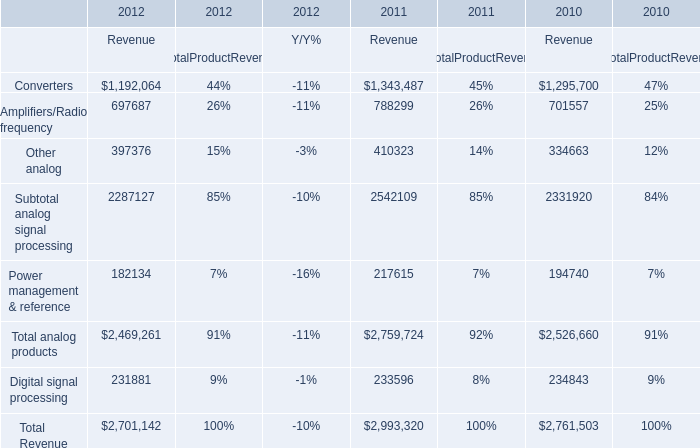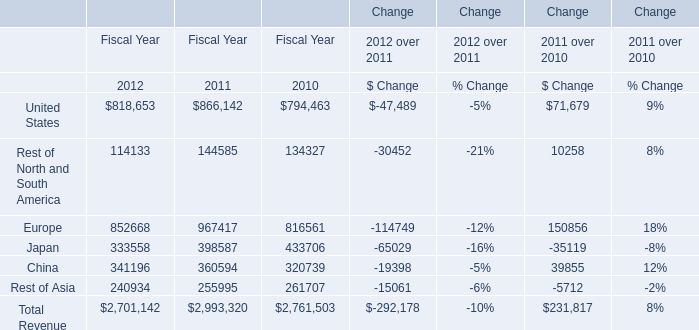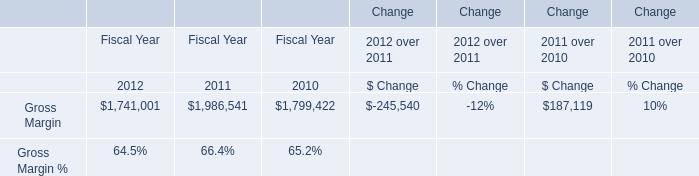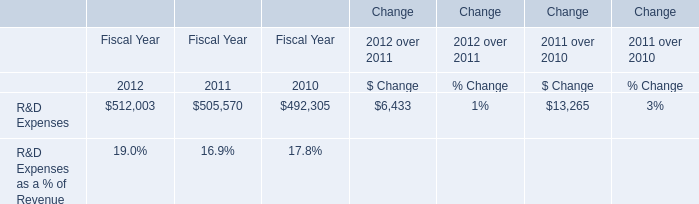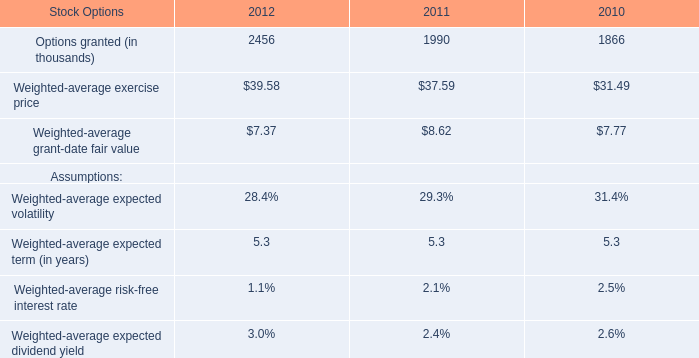If Converters develops with the same increasing rate in 2012, what will it reach in 2013? 
Computations: ((1 + ((1192064 - 1343487) / 1343487)) * 1192064)
Answer: 1057707.72631. 